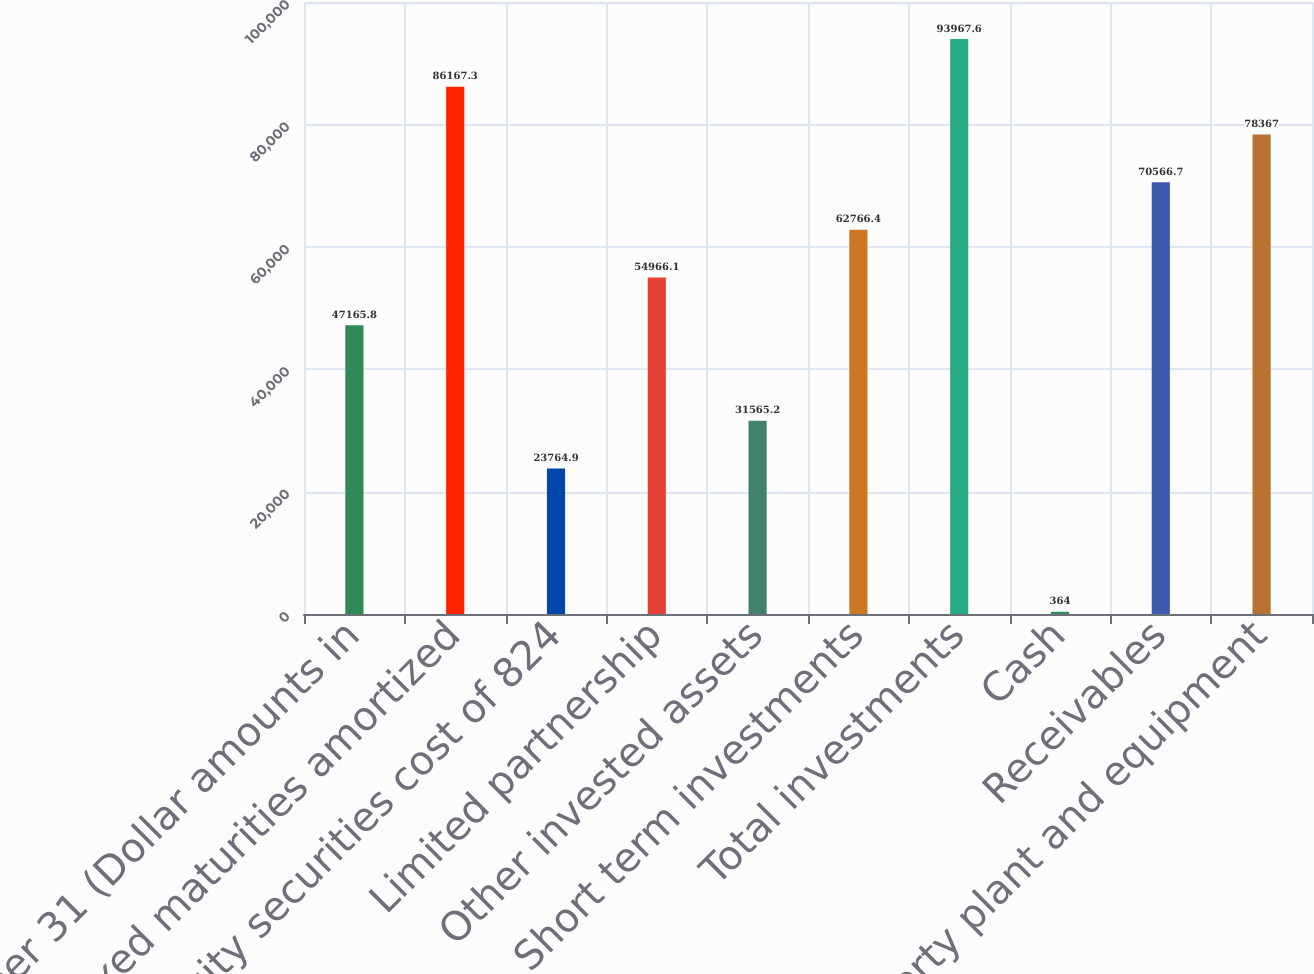Convert chart to OTSL. <chart><loc_0><loc_0><loc_500><loc_500><bar_chart><fcel>December 31 (Dollar amounts in<fcel>Fixed maturities amortized<fcel>Equity securities cost of 824<fcel>Limited partnership<fcel>Other invested assets<fcel>Short term investments<fcel>Total investments<fcel>Cash<fcel>Receivables<fcel>Property plant and equipment<nl><fcel>47165.8<fcel>86167.3<fcel>23764.9<fcel>54966.1<fcel>31565.2<fcel>62766.4<fcel>93967.6<fcel>364<fcel>70566.7<fcel>78367<nl></chart> 